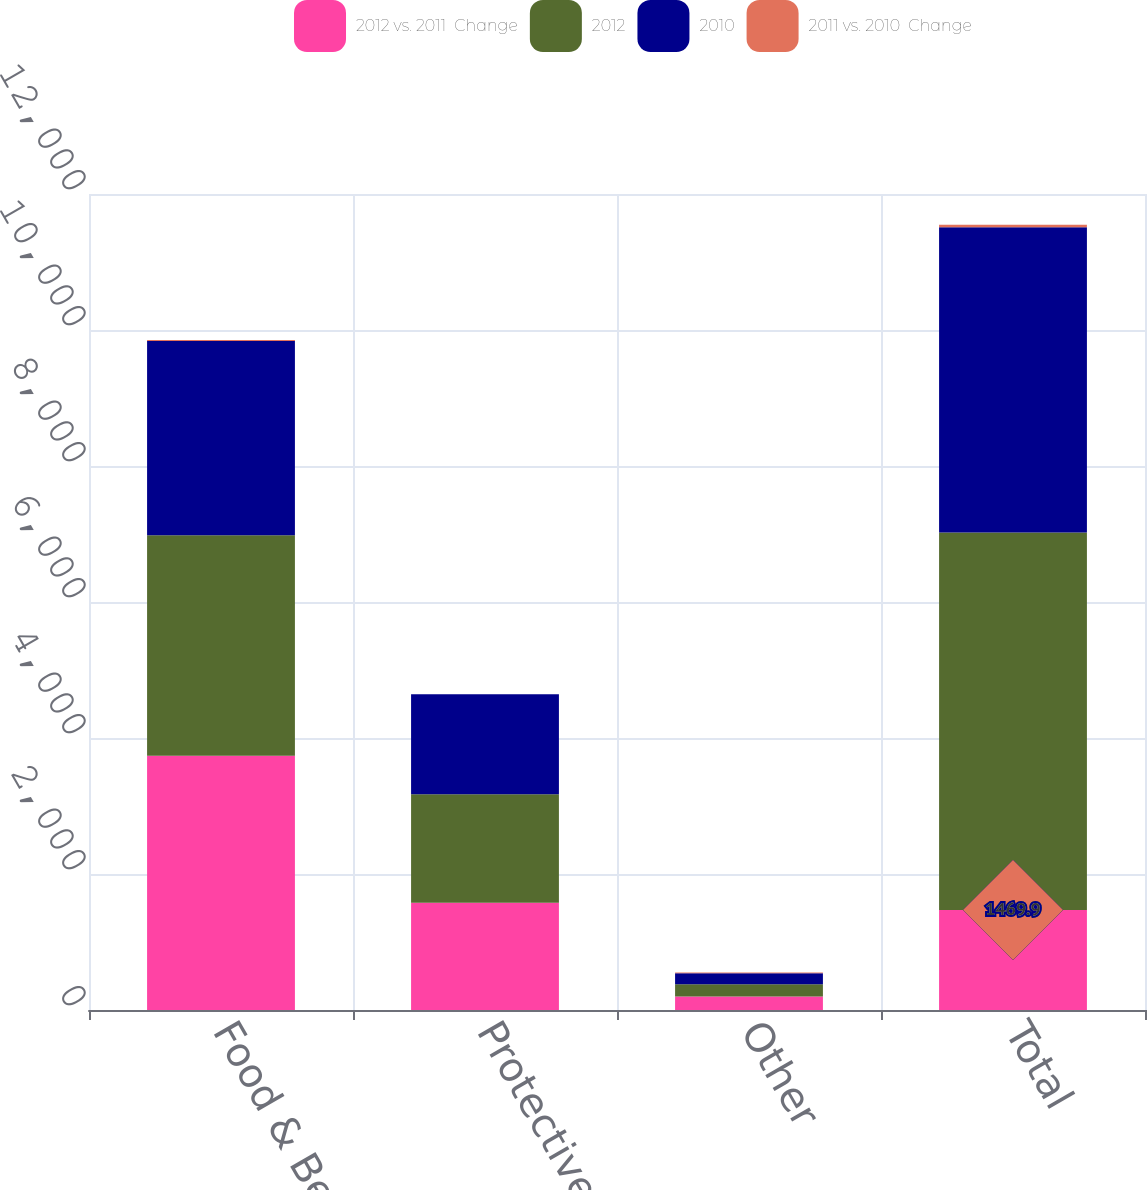Convert chart. <chart><loc_0><loc_0><loc_500><loc_500><stacked_bar_chart><ecel><fcel>Food & Beverage<fcel>Protective Packaging<fcel>Other<fcel>Total<nl><fcel>2012 vs. 2011  Change<fcel>3739.6<fcel>1578.4<fcel>198.6<fcel>1469.9<nl><fcel>2012<fcel>3240.6<fcel>1594.4<fcel>181.9<fcel>5550.9<nl><fcel>2010<fcel>2858.5<fcel>1469.9<fcel>161.7<fcel>4490.1<nl><fcel>2011 vs. 2010  Change<fcel>15<fcel>1<fcel>9<fcel>38<nl></chart> 